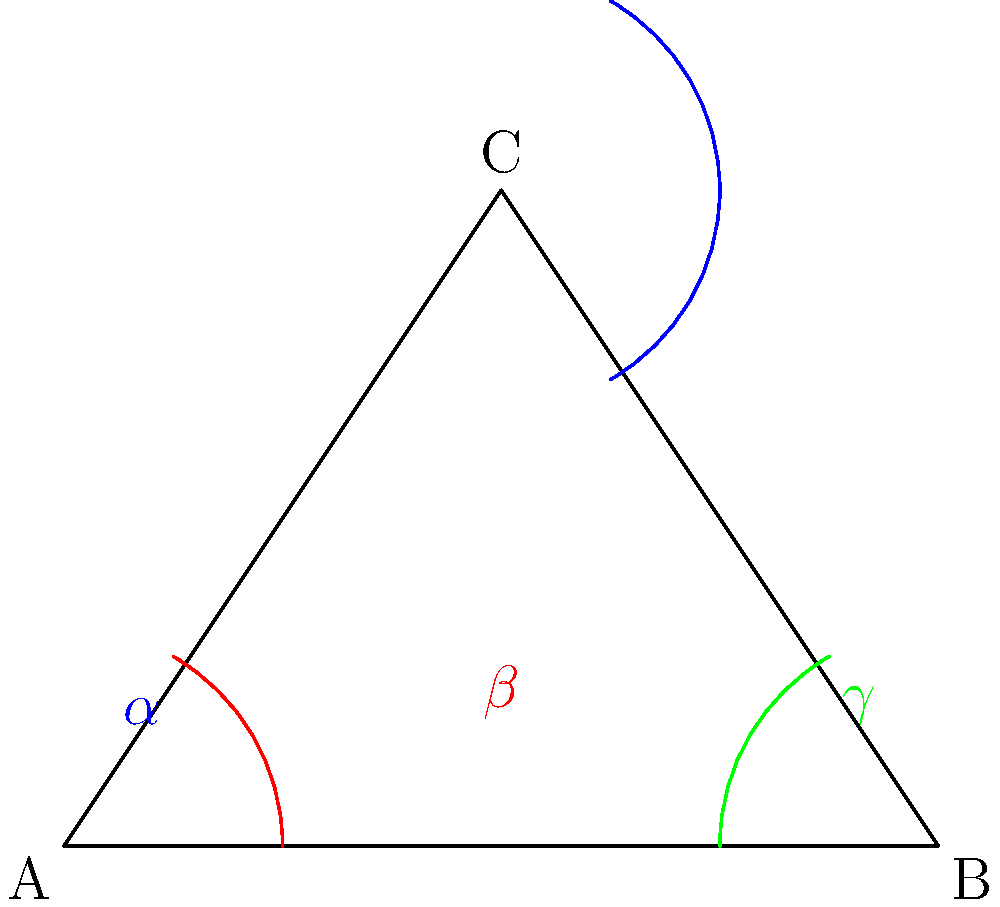In the glamorous world of hairstyling, angular proportions can make or break a look! If the angles of a triangular updo are in a 3:4:5 ratio, and the smallest angle is a sassy 40°, what's the measure of the most dramatic angle? (Hint: It's as attention-grabbing as a surprise twist in a beauty pageant!) Let's style this problem step by step:

1) First, let's identify our angles. We'll call them $\alpha$, $\beta$, and $\gamma$ in order from smallest to largest.

2) We know the ratio is 3:4:5, so:
   $\alpha : \beta : \gamma = 3 : 4 : 5$

3) We're told that $\alpha = 40°$ (the smallest angle)

4) Now, let's set up a proportion:
   $\frac{\alpha}{3} = \frac{\beta}{4} = \frac{\gamma}{5} = \frac{40°}{3}$

5) From this, we can find the value of one "part" in our ratio:
   $\frac{40°}{3} = 13.33°$

6) Now we can calculate each angle:
   $\alpha = 3 * 13.33° = 40°$ (which we already knew)
   $\beta = 4 * 13.33° = 53.33°$
   $\gamma = 5 * 13.33° = 66.67°$

7) The question asks for the largest angle, which is $\gamma$.

8) Rounding to the nearest whole number (because who has time for decimals in a beauty contest?), we get 67°.
Answer: 67° 